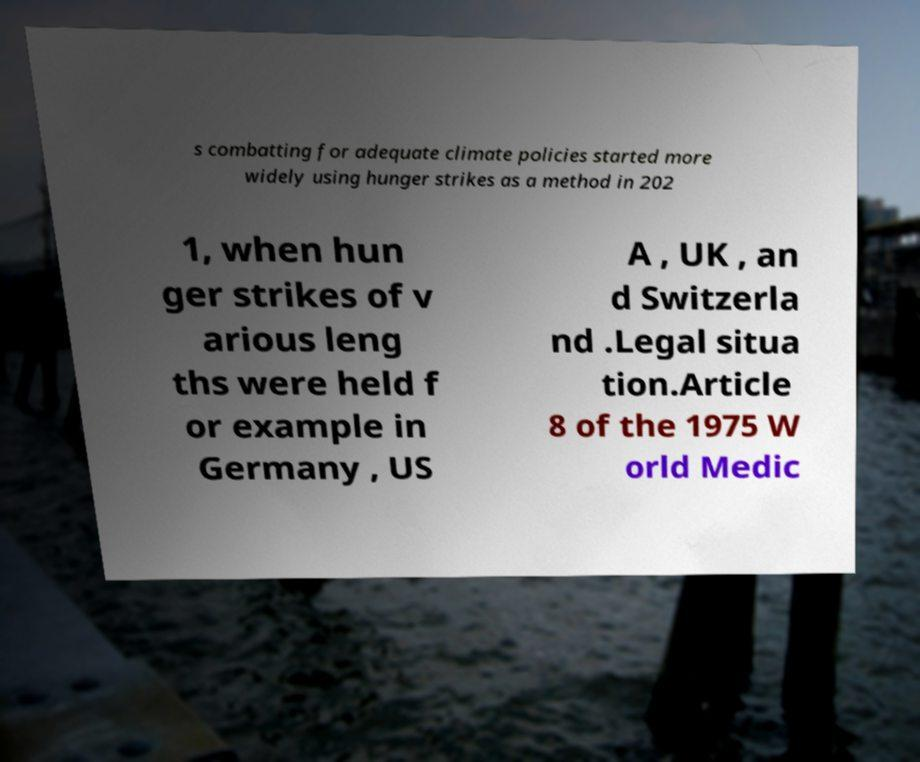Can you read and provide the text displayed in the image?This photo seems to have some interesting text. Can you extract and type it out for me? s combatting for adequate climate policies started more widely using hunger strikes as a method in 202 1, when hun ger strikes of v arious leng ths were held f or example in Germany , US A , UK , an d Switzerla nd .Legal situa tion.Article 8 of the 1975 W orld Medic 